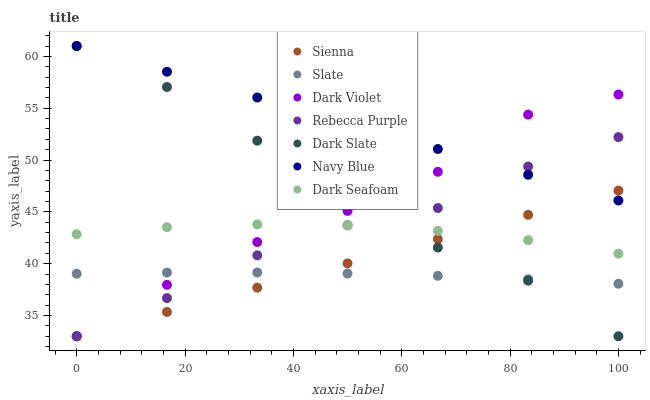Does Slate have the minimum area under the curve?
Answer yes or no. Yes. Does Navy Blue have the maximum area under the curve?
Answer yes or no. Yes. Does Dark Violet have the minimum area under the curve?
Answer yes or no. No. Does Dark Violet have the maximum area under the curve?
Answer yes or no. No. Is Sienna the smoothest?
Answer yes or no. Yes. Is Dark Slate the roughest?
Answer yes or no. Yes. Is Slate the smoothest?
Answer yes or no. No. Is Slate the roughest?
Answer yes or no. No. Does Dark Violet have the lowest value?
Answer yes or no. Yes. Does Slate have the lowest value?
Answer yes or no. No. Does Dark Slate have the highest value?
Answer yes or no. Yes. Does Dark Violet have the highest value?
Answer yes or no. No. Is Slate less than Dark Seafoam?
Answer yes or no. Yes. Is Navy Blue greater than Dark Seafoam?
Answer yes or no. Yes. Does Rebecca Purple intersect Dark Seafoam?
Answer yes or no. Yes. Is Rebecca Purple less than Dark Seafoam?
Answer yes or no. No. Is Rebecca Purple greater than Dark Seafoam?
Answer yes or no. No. Does Slate intersect Dark Seafoam?
Answer yes or no. No. 